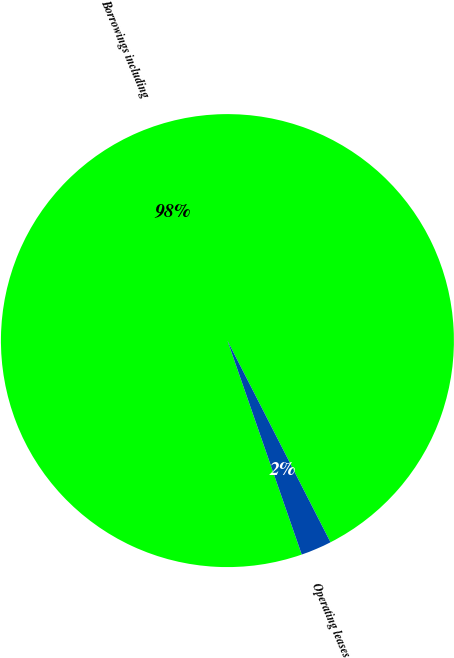<chart> <loc_0><loc_0><loc_500><loc_500><pie_chart><fcel>Borrowings including<fcel>Operating leases<nl><fcel>97.8%<fcel>2.2%<nl></chart> 